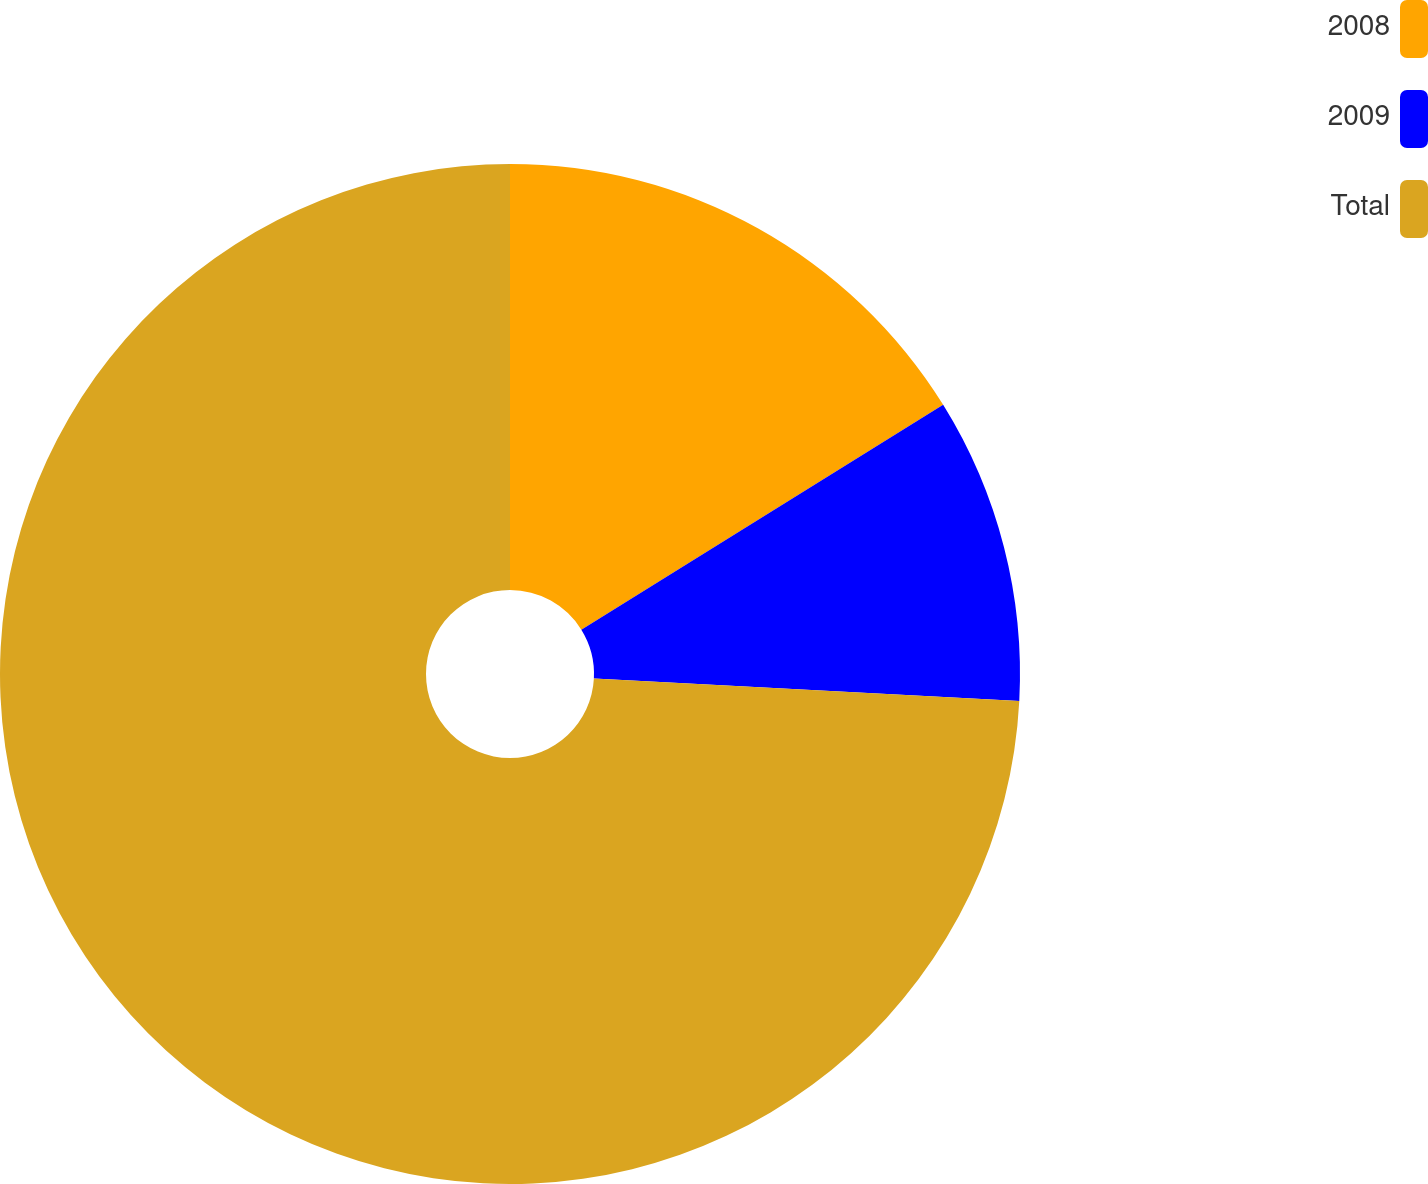Convert chart to OTSL. <chart><loc_0><loc_0><loc_500><loc_500><pie_chart><fcel>2008<fcel>2009<fcel>Total<nl><fcel>16.15%<fcel>9.69%<fcel>74.16%<nl></chart> 